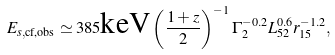Convert formula to latex. <formula><loc_0><loc_0><loc_500><loc_500>E _ { s , \text {cf,obs} } \simeq 3 8 5 \text {keV} \left ( \frac { 1 + z } { 2 } \right ) ^ { - 1 } \Gamma _ { 2 } ^ { - 0 . 2 } L _ { 5 2 } ^ { 0 . 6 } r _ { 1 5 } ^ { - 1 . 2 } ,</formula> 